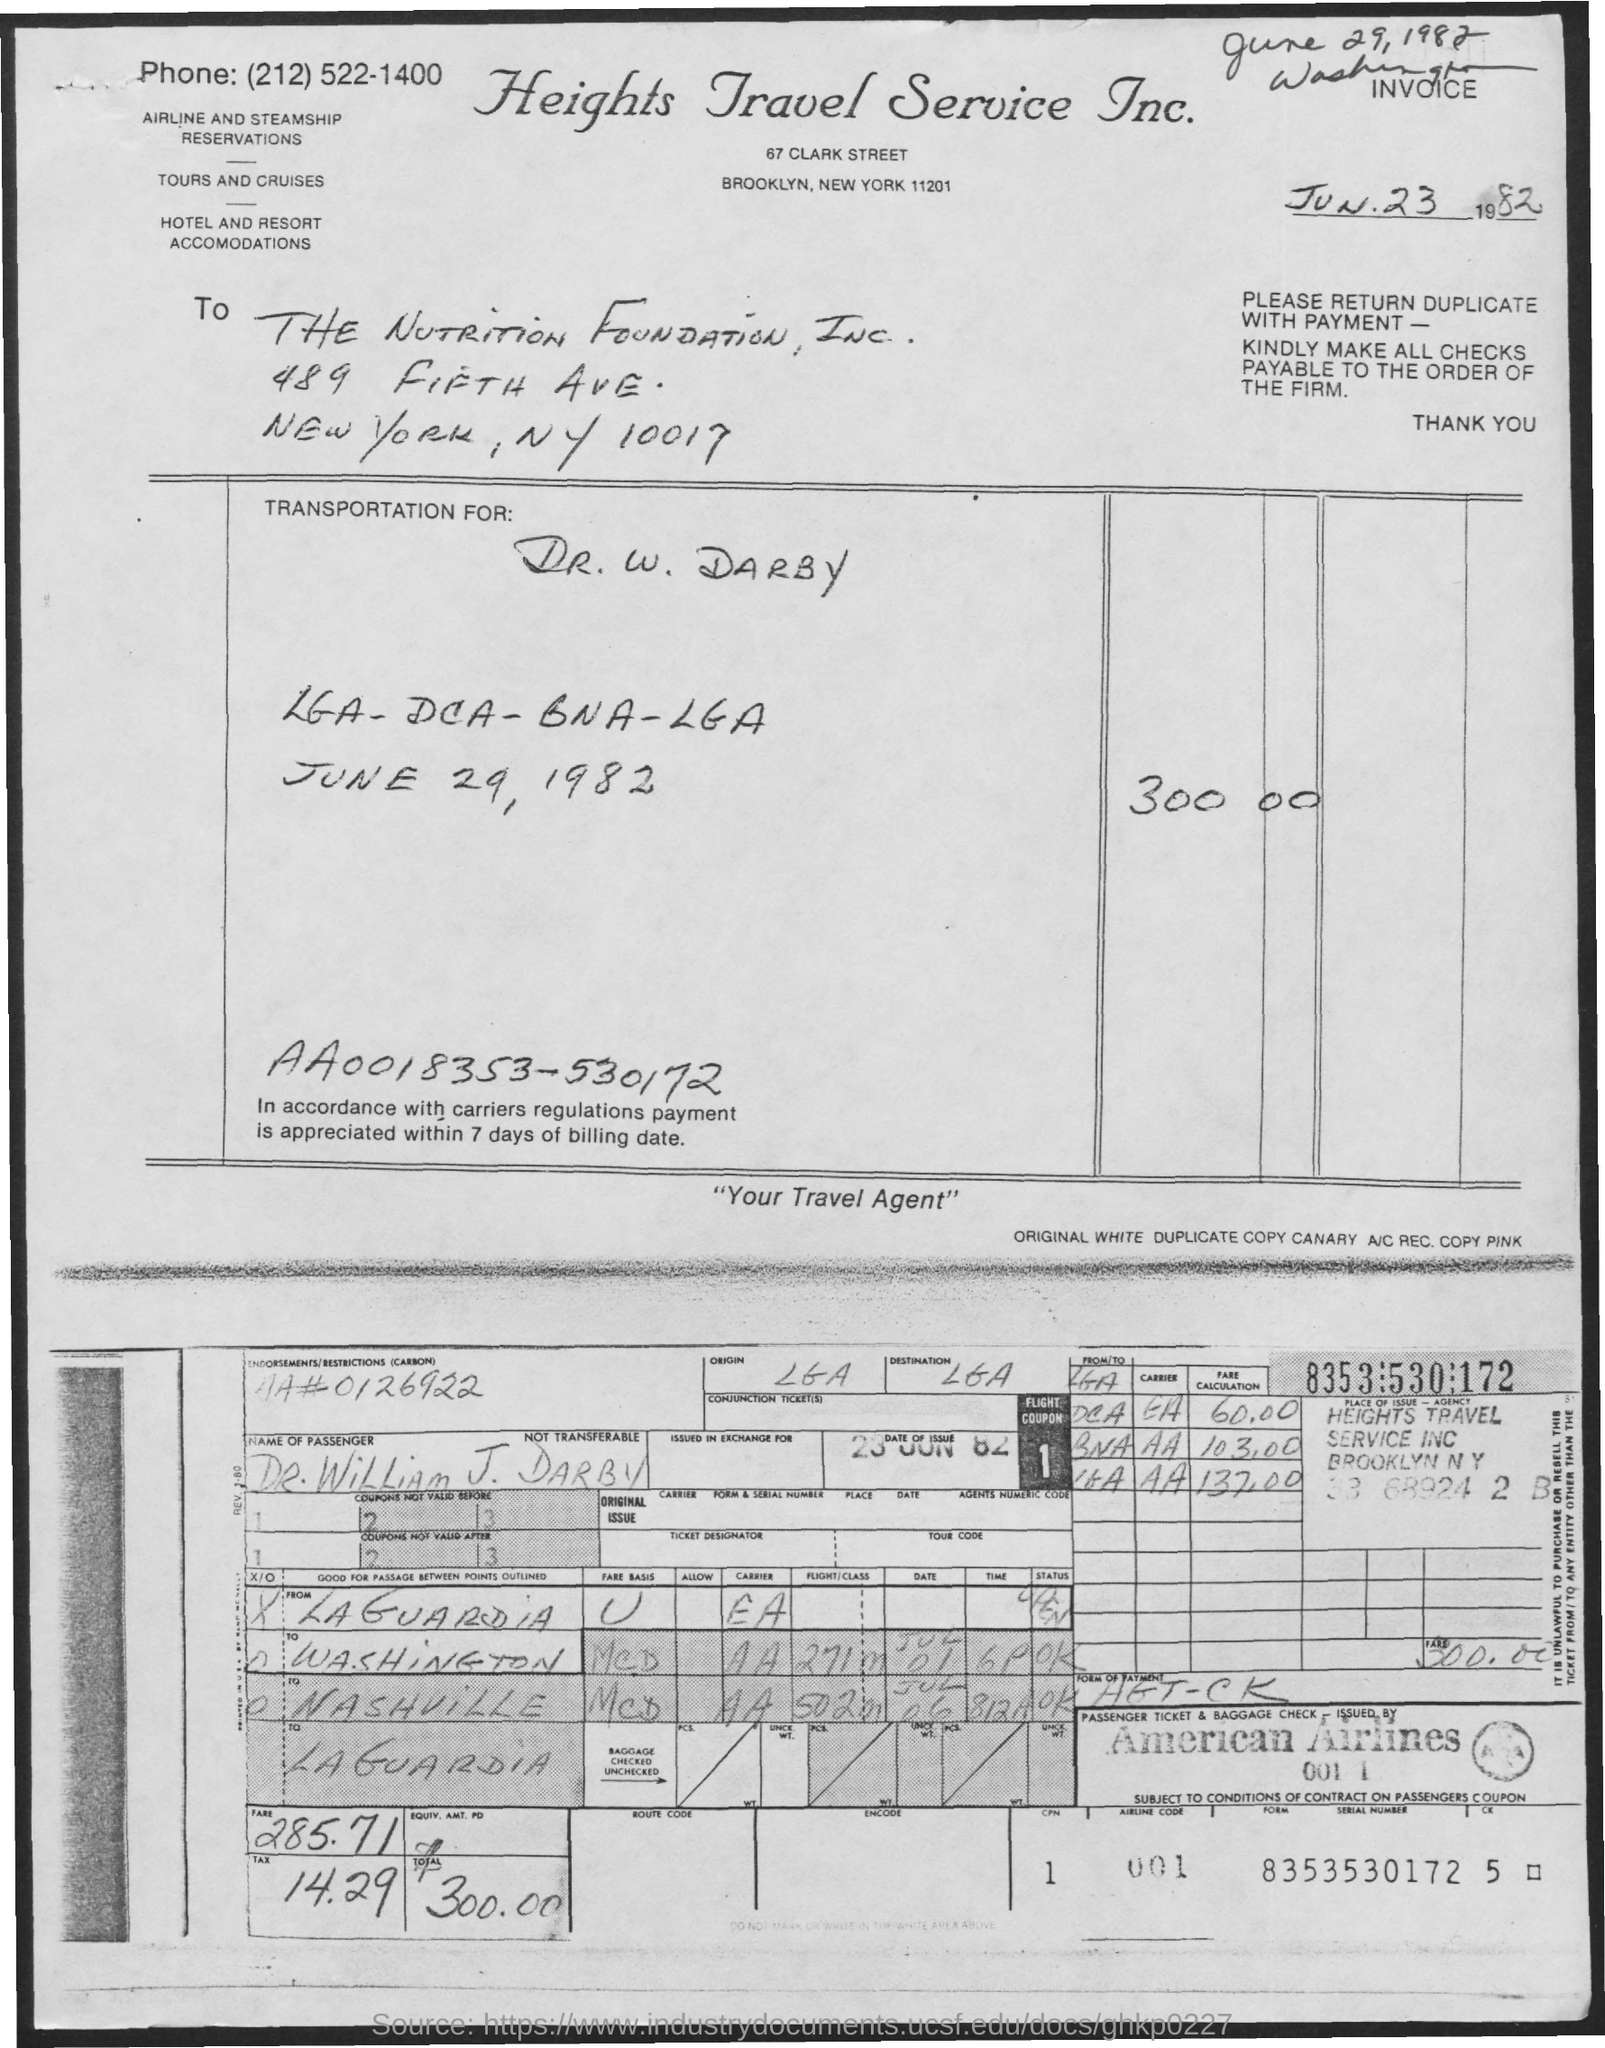What is the zip code for Heights travel service Inc.?
Offer a very short reply. 11201. What is the phone number of heights travel service inc.?
Offer a terse response. (212)522-1400. What is the postal code for nutrition foundation?
Offer a very short reply. 10017. What is the tagline of heights travel service inc. in quotations below?
Your response must be concise. "your travel agent". What is the date of issue of invoice?
Offer a terse response. Jun.23 1982. 